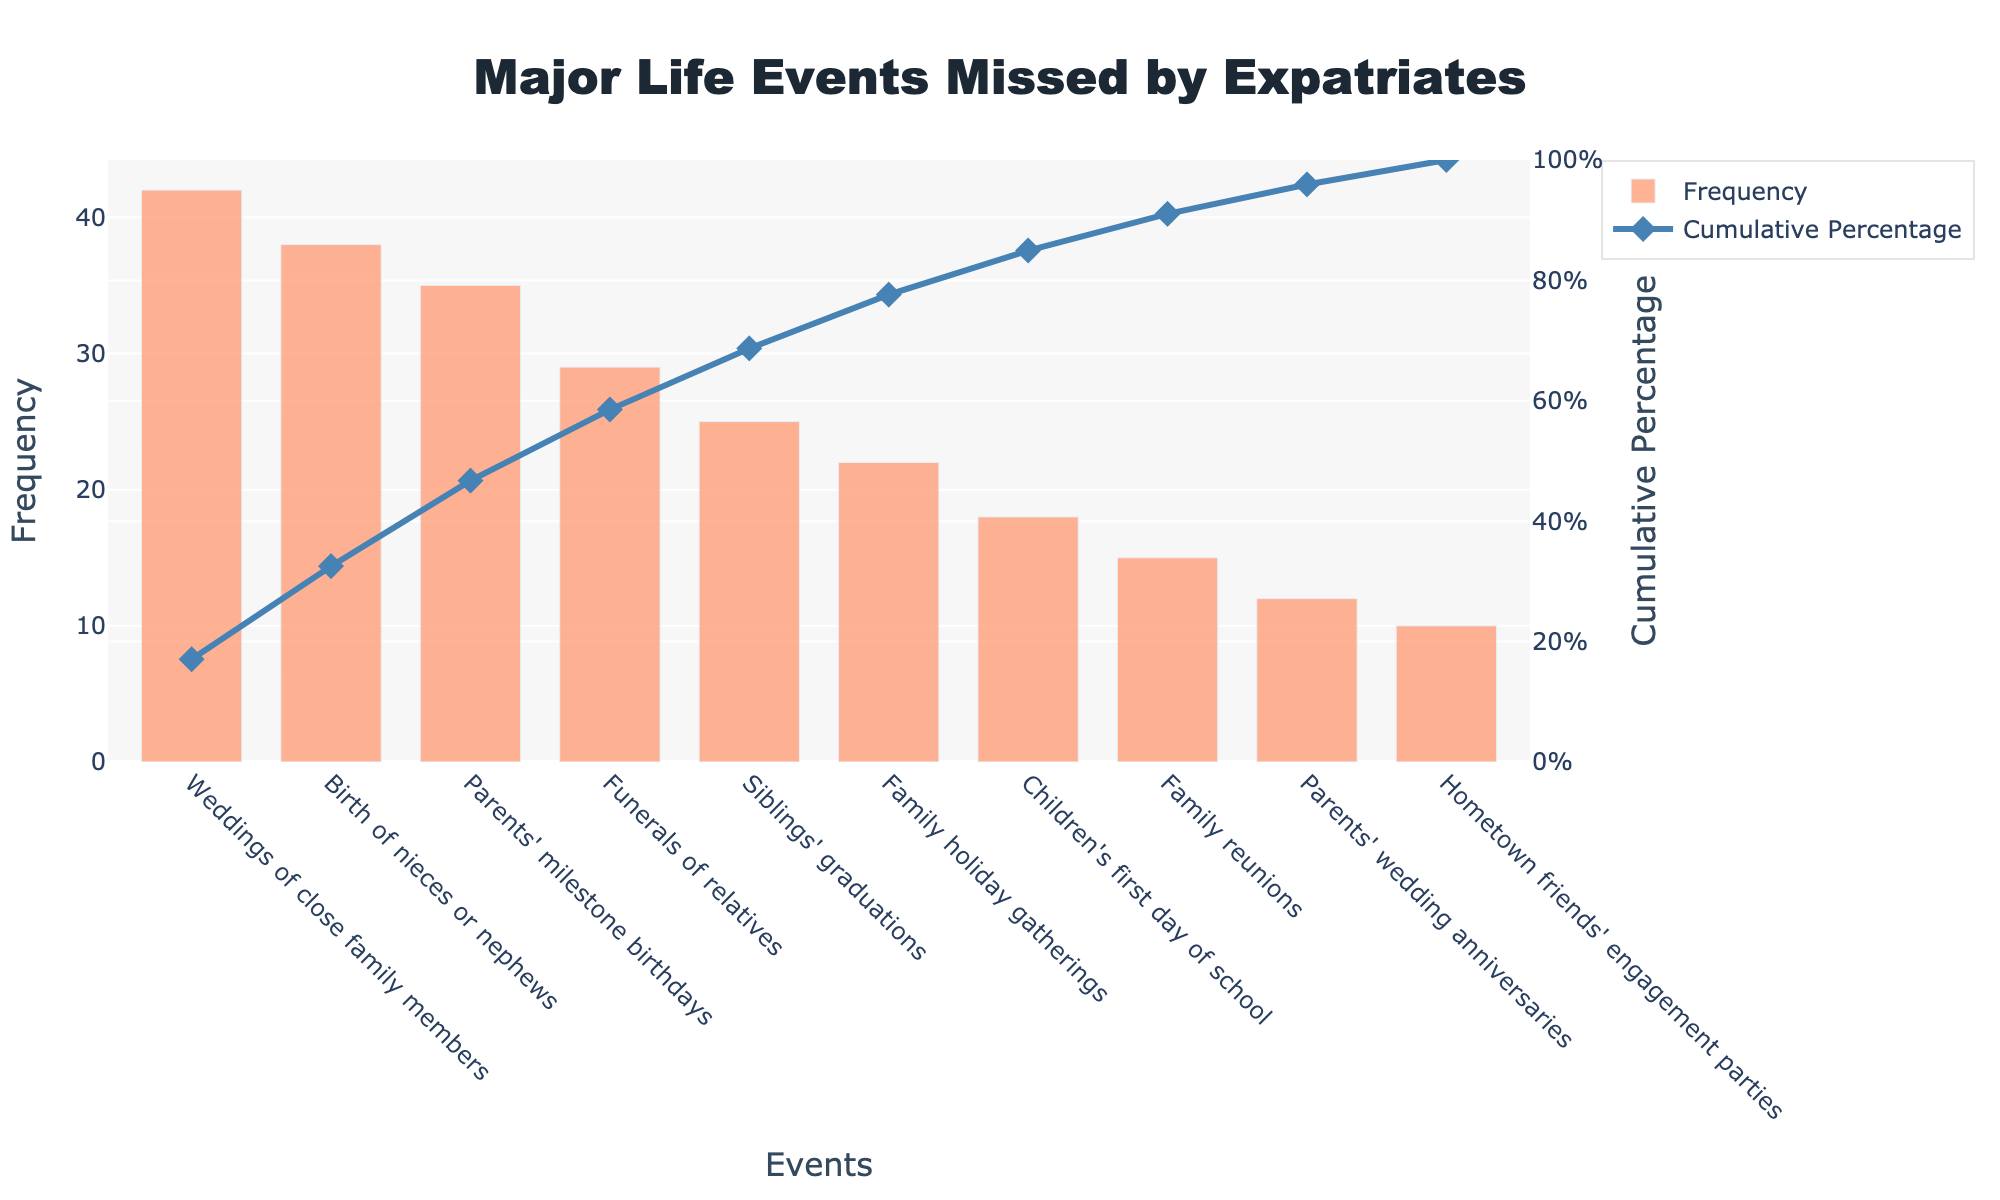Which major life event has the highest frequency of being missed by expatriates? The Pareto chart shows different life events on the x-axis and their frequencies on the y-axis. The highest bar represents the event with the highest frequency.
Answer: Weddings of close family members What is the cumulative percentage of the top 3 most-missed events? To find the cumulative percentage of the top 3 events, sum the y-values for 'Weddings of close family members', 'Birth of nieces or nephews', and 'Parents' milestone birthdays', then refer to the cumulative percentage data for these events. According to the chart, these cumulative percentages are approximately 23%, 45%, and 63%.
Answer: 63% Which event category is the fourth most missed? By counting the bars from left to right on the x-axis, the fourth bar corresponds to 'Funerals of relatives'.
Answer: Funerals of relatives How many events have a frequency of 20 or more? Scan the y-values of the bars, and count the ones that have a height equal to or exceeding 20.
Answer: Six events What is the frequency value of 'Parents' wedding anniversaries'? Locate the bar representing 'Parents' wedding anniversaries' on the x-axis, and check its corresponding height on the y-axis.
Answer: 12 By what percentage does the 'Birth of nieces or nephews' contribute to the cumulative percentage? Refer to the cumulative percentage on the line graph for 'Birth of nieces or nephews'.
Answer: Approximately 22% Compare the misses of 'Siblings' graduations' and 'Family holiday gatherings'. Which one is higher? Identify the bars for 'Siblings' graduations' and 'Family holiday gatherings' on the x-axis and compare their heights.
Answer: Siblings' graduations What cumulative percentage does the 'Family reunions' reach? Find 'Family reunions' on the x-axis and read off the cumulative percentage from the line graph.
Answer: Approximately 84% Is the frequency of 'Hometown friends' engagement parties' more or less than half the frequency of 'Weddings of close family members'? Compare the frequency values of 'Hometown friends' engagement parties' (10) and half the value of 'Weddings of close family members' (21).
Answer: Less What's the combined frequency of the three least missed events? Find the frequencies of the three least missed events—'Family reunions' (15), 'Parents' wedding anniversaries' (12), and 'Hometown friends' engagement parties' (10)—and sum them up: 15 + 12 + 10.
Answer: 37 